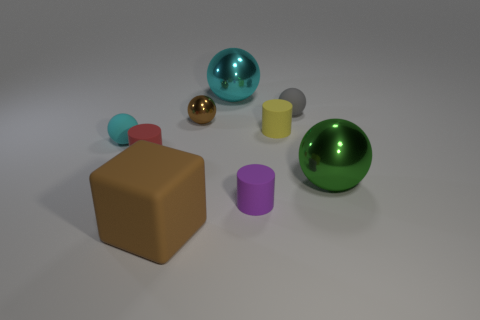Is the color of the big thing on the left side of the brown metallic ball the same as the small shiny thing? The big object on the left, which appears to be a brown cube, does share a similar hue with the smaller cylindrical object lying in front of the green metallic sphere. Both exhibit shades of tan or beige, indicative of a general color similarity. 